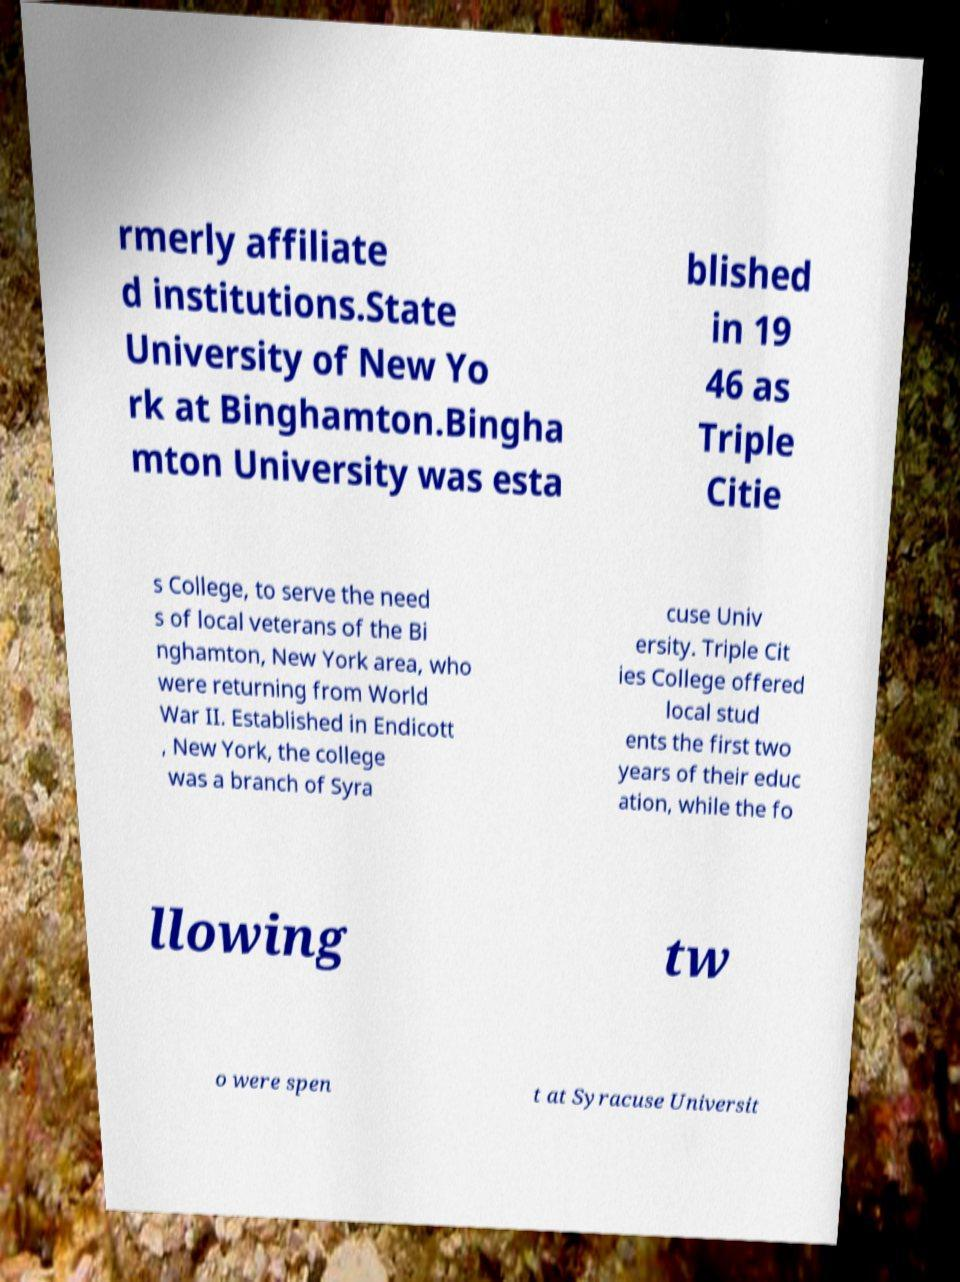I need the written content from this picture converted into text. Can you do that? rmerly affiliate d institutions.State University of New Yo rk at Binghamton.Bingha mton University was esta blished in 19 46 as Triple Citie s College, to serve the need s of local veterans of the Bi nghamton, New York area, who were returning from World War II. Established in Endicott , New York, the college was a branch of Syra cuse Univ ersity. Triple Cit ies College offered local stud ents the first two years of their educ ation, while the fo llowing tw o were spen t at Syracuse Universit 